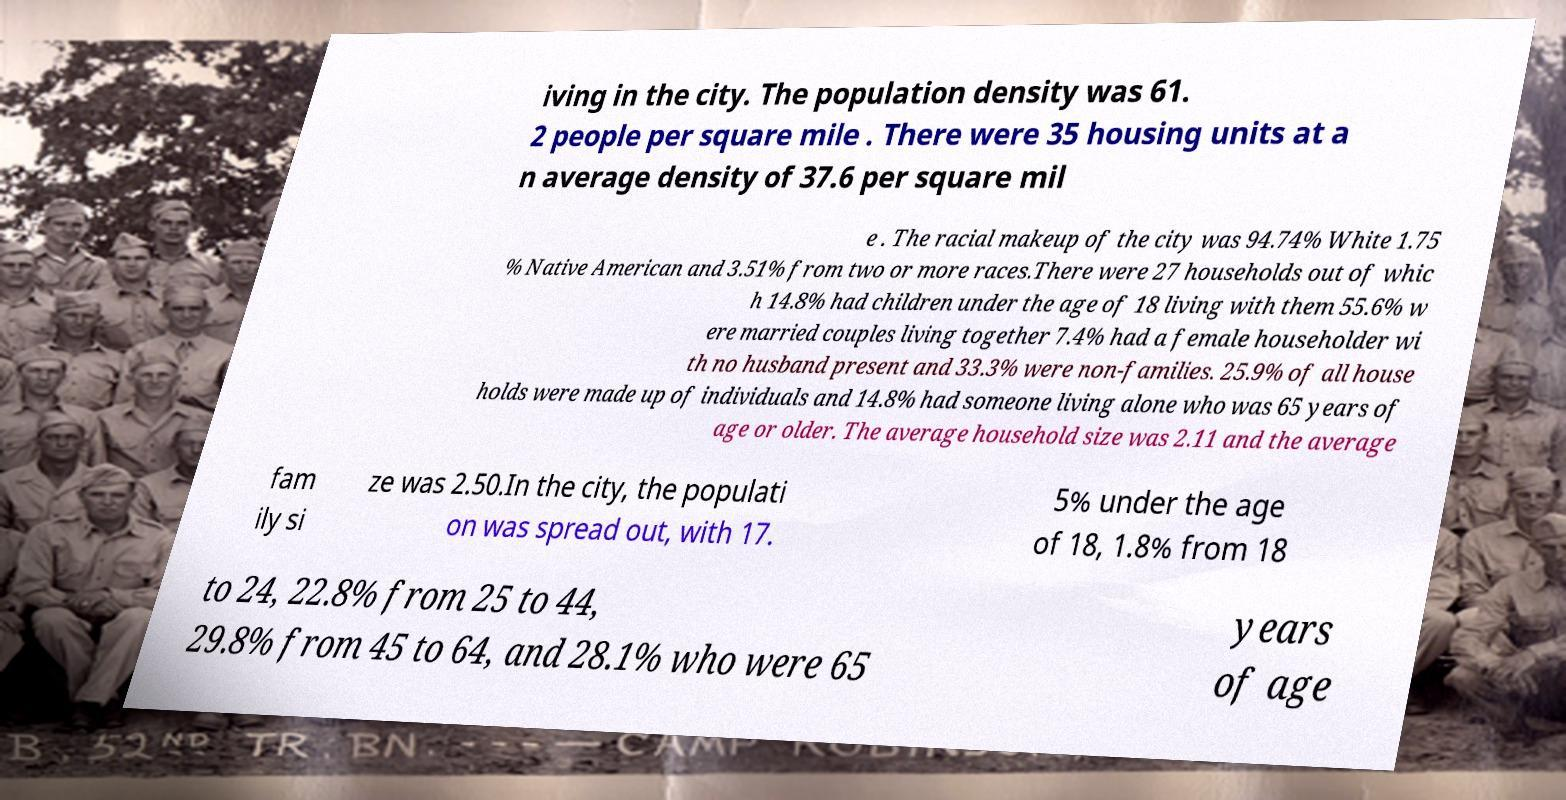Could you extract and type out the text from this image? iving in the city. The population density was 61. 2 people per square mile . There were 35 housing units at a n average density of 37.6 per square mil e . The racial makeup of the city was 94.74% White 1.75 % Native American and 3.51% from two or more races.There were 27 households out of whic h 14.8% had children under the age of 18 living with them 55.6% w ere married couples living together 7.4% had a female householder wi th no husband present and 33.3% were non-families. 25.9% of all house holds were made up of individuals and 14.8% had someone living alone who was 65 years of age or older. The average household size was 2.11 and the average fam ily si ze was 2.50.In the city, the populati on was spread out, with 17. 5% under the age of 18, 1.8% from 18 to 24, 22.8% from 25 to 44, 29.8% from 45 to 64, and 28.1% who were 65 years of age 